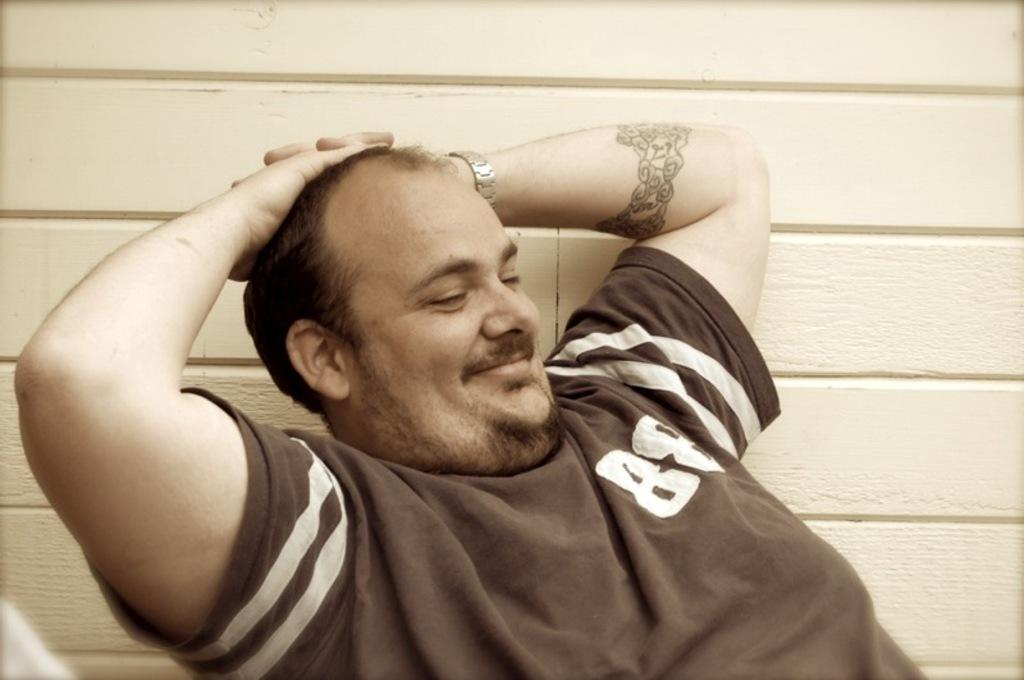Who is present in the image? There is a man in the image. What is the man's facial expression? The man is smiling. What can be seen in the background of the image? There is a wall in the background of the image. What type of chain is the horse wearing in the image? There is no horse or chain present in the image; it features a man who is smiling. How does the airplane contribute to the man's smile in the image? There is no airplane present in the image, so it cannot contribute to the man's smile. 